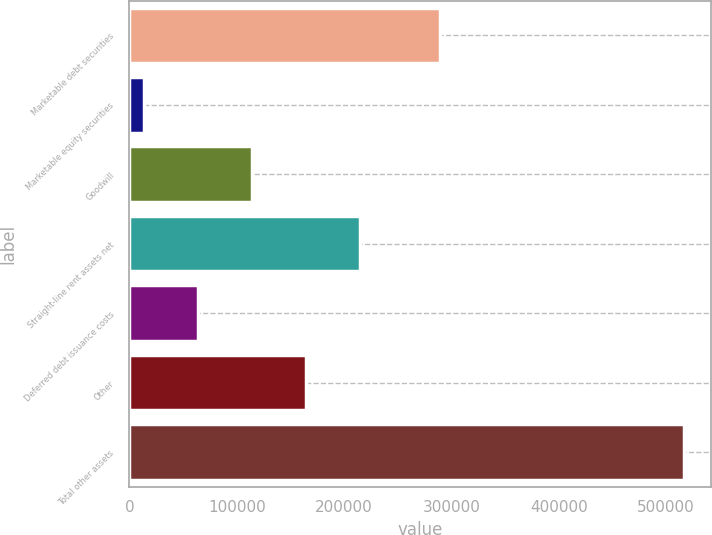<chart> <loc_0><loc_0><loc_500><loc_500><bar_chart><fcel>Marketable debt securities<fcel>Marketable equity securities<fcel>Goodwill<fcel>Straight-line rent assets net<fcel>Deferred debt issuance costs<fcel>Other<fcel>Total other assets<nl><fcel>289163<fcel>13933<fcel>114373<fcel>214813<fcel>64153<fcel>164593<fcel>516133<nl></chart> 